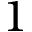Convert formula to latex. <formula><loc_0><loc_0><loc_500><loc_500>1</formula> 